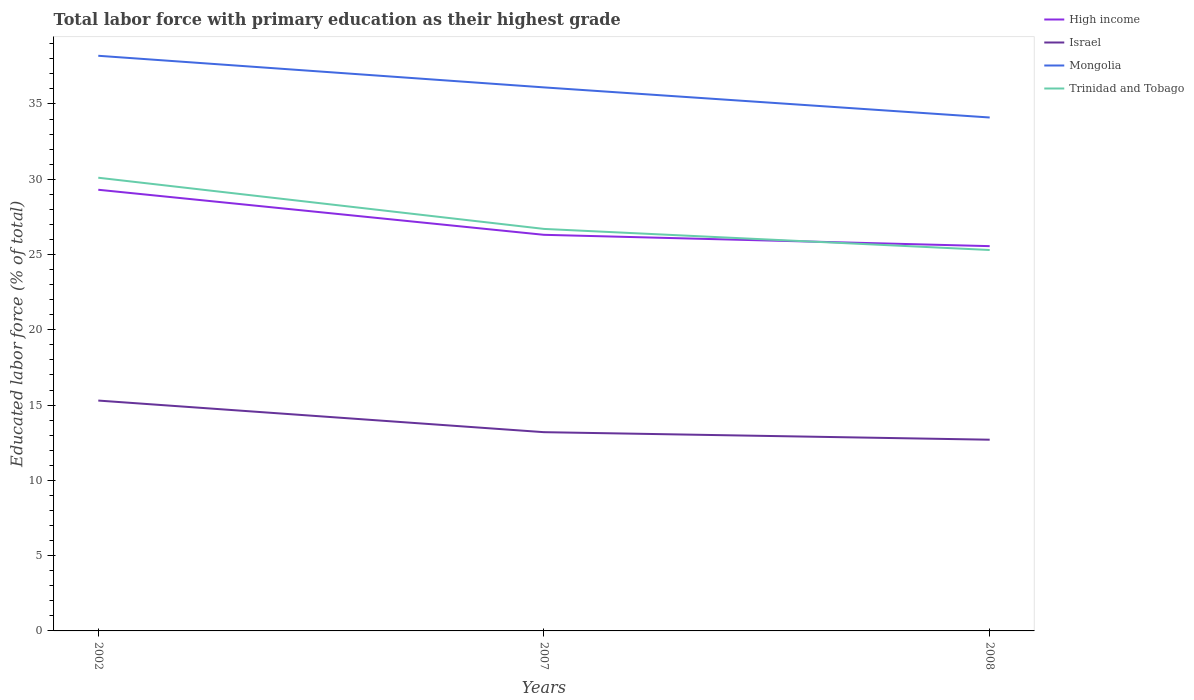Across all years, what is the maximum percentage of total labor force with primary education in Trinidad and Tobago?
Provide a succinct answer. 25.3. In which year was the percentage of total labor force with primary education in High income maximum?
Give a very brief answer. 2008. What is the difference between the highest and the second highest percentage of total labor force with primary education in Trinidad and Tobago?
Your answer should be very brief. 4.8. Are the values on the major ticks of Y-axis written in scientific E-notation?
Give a very brief answer. No. Does the graph contain any zero values?
Offer a very short reply. No. Where does the legend appear in the graph?
Offer a terse response. Top right. How many legend labels are there?
Make the answer very short. 4. How are the legend labels stacked?
Ensure brevity in your answer.  Vertical. What is the title of the graph?
Your response must be concise. Total labor force with primary education as their highest grade. What is the label or title of the X-axis?
Provide a short and direct response. Years. What is the label or title of the Y-axis?
Offer a terse response. Educated labor force (% of total). What is the Educated labor force (% of total) of High income in 2002?
Ensure brevity in your answer.  29.3. What is the Educated labor force (% of total) of Israel in 2002?
Provide a short and direct response. 15.3. What is the Educated labor force (% of total) of Mongolia in 2002?
Provide a succinct answer. 38.2. What is the Educated labor force (% of total) in Trinidad and Tobago in 2002?
Your response must be concise. 30.1. What is the Educated labor force (% of total) in High income in 2007?
Offer a very short reply. 26.31. What is the Educated labor force (% of total) in Israel in 2007?
Your answer should be compact. 13.2. What is the Educated labor force (% of total) of Mongolia in 2007?
Offer a terse response. 36.1. What is the Educated labor force (% of total) of Trinidad and Tobago in 2007?
Keep it short and to the point. 26.7. What is the Educated labor force (% of total) in High income in 2008?
Offer a terse response. 25.56. What is the Educated labor force (% of total) of Israel in 2008?
Your answer should be very brief. 12.7. What is the Educated labor force (% of total) of Mongolia in 2008?
Offer a terse response. 34.1. What is the Educated labor force (% of total) in Trinidad and Tobago in 2008?
Ensure brevity in your answer.  25.3. Across all years, what is the maximum Educated labor force (% of total) in High income?
Your response must be concise. 29.3. Across all years, what is the maximum Educated labor force (% of total) of Israel?
Ensure brevity in your answer.  15.3. Across all years, what is the maximum Educated labor force (% of total) in Mongolia?
Provide a short and direct response. 38.2. Across all years, what is the maximum Educated labor force (% of total) in Trinidad and Tobago?
Offer a very short reply. 30.1. Across all years, what is the minimum Educated labor force (% of total) of High income?
Your response must be concise. 25.56. Across all years, what is the minimum Educated labor force (% of total) in Israel?
Make the answer very short. 12.7. Across all years, what is the minimum Educated labor force (% of total) of Mongolia?
Provide a succinct answer. 34.1. Across all years, what is the minimum Educated labor force (% of total) of Trinidad and Tobago?
Keep it short and to the point. 25.3. What is the total Educated labor force (% of total) in High income in the graph?
Your answer should be compact. 81.17. What is the total Educated labor force (% of total) of Israel in the graph?
Ensure brevity in your answer.  41.2. What is the total Educated labor force (% of total) of Mongolia in the graph?
Give a very brief answer. 108.4. What is the total Educated labor force (% of total) in Trinidad and Tobago in the graph?
Your response must be concise. 82.1. What is the difference between the Educated labor force (% of total) of High income in 2002 and that in 2007?
Your answer should be very brief. 2.99. What is the difference between the Educated labor force (% of total) in Mongolia in 2002 and that in 2007?
Offer a very short reply. 2.1. What is the difference between the Educated labor force (% of total) of High income in 2002 and that in 2008?
Your answer should be very brief. 3.74. What is the difference between the Educated labor force (% of total) in Trinidad and Tobago in 2002 and that in 2008?
Give a very brief answer. 4.8. What is the difference between the Educated labor force (% of total) of High income in 2007 and that in 2008?
Ensure brevity in your answer.  0.75. What is the difference between the Educated labor force (% of total) in High income in 2002 and the Educated labor force (% of total) in Israel in 2007?
Keep it short and to the point. 16.1. What is the difference between the Educated labor force (% of total) in High income in 2002 and the Educated labor force (% of total) in Mongolia in 2007?
Make the answer very short. -6.8. What is the difference between the Educated labor force (% of total) in High income in 2002 and the Educated labor force (% of total) in Trinidad and Tobago in 2007?
Make the answer very short. 2.6. What is the difference between the Educated labor force (% of total) in Israel in 2002 and the Educated labor force (% of total) in Mongolia in 2007?
Keep it short and to the point. -20.8. What is the difference between the Educated labor force (% of total) of Mongolia in 2002 and the Educated labor force (% of total) of Trinidad and Tobago in 2007?
Provide a succinct answer. 11.5. What is the difference between the Educated labor force (% of total) of High income in 2002 and the Educated labor force (% of total) of Israel in 2008?
Your answer should be very brief. 16.6. What is the difference between the Educated labor force (% of total) in High income in 2002 and the Educated labor force (% of total) in Mongolia in 2008?
Provide a succinct answer. -4.8. What is the difference between the Educated labor force (% of total) of High income in 2002 and the Educated labor force (% of total) of Trinidad and Tobago in 2008?
Your answer should be compact. 4. What is the difference between the Educated labor force (% of total) of Israel in 2002 and the Educated labor force (% of total) of Mongolia in 2008?
Give a very brief answer. -18.8. What is the difference between the Educated labor force (% of total) in Israel in 2002 and the Educated labor force (% of total) in Trinidad and Tobago in 2008?
Your answer should be compact. -10. What is the difference between the Educated labor force (% of total) of High income in 2007 and the Educated labor force (% of total) of Israel in 2008?
Offer a terse response. 13.61. What is the difference between the Educated labor force (% of total) in High income in 2007 and the Educated labor force (% of total) in Mongolia in 2008?
Keep it short and to the point. -7.79. What is the difference between the Educated labor force (% of total) of High income in 2007 and the Educated labor force (% of total) of Trinidad and Tobago in 2008?
Keep it short and to the point. 1.01. What is the difference between the Educated labor force (% of total) of Israel in 2007 and the Educated labor force (% of total) of Mongolia in 2008?
Your answer should be compact. -20.9. What is the average Educated labor force (% of total) in High income per year?
Ensure brevity in your answer.  27.06. What is the average Educated labor force (% of total) of Israel per year?
Offer a very short reply. 13.73. What is the average Educated labor force (% of total) of Mongolia per year?
Keep it short and to the point. 36.13. What is the average Educated labor force (% of total) in Trinidad and Tobago per year?
Keep it short and to the point. 27.37. In the year 2002, what is the difference between the Educated labor force (% of total) of High income and Educated labor force (% of total) of Israel?
Your answer should be very brief. 14. In the year 2002, what is the difference between the Educated labor force (% of total) in High income and Educated labor force (% of total) in Mongolia?
Offer a terse response. -8.9. In the year 2002, what is the difference between the Educated labor force (% of total) in High income and Educated labor force (% of total) in Trinidad and Tobago?
Offer a very short reply. -0.8. In the year 2002, what is the difference between the Educated labor force (% of total) of Israel and Educated labor force (% of total) of Mongolia?
Ensure brevity in your answer.  -22.9. In the year 2002, what is the difference between the Educated labor force (% of total) in Israel and Educated labor force (% of total) in Trinidad and Tobago?
Provide a succinct answer. -14.8. In the year 2007, what is the difference between the Educated labor force (% of total) of High income and Educated labor force (% of total) of Israel?
Make the answer very short. 13.11. In the year 2007, what is the difference between the Educated labor force (% of total) of High income and Educated labor force (% of total) of Mongolia?
Your response must be concise. -9.79. In the year 2007, what is the difference between the Educated labor force (% of total) in High income and Educated labor force (% of total) in Trinidad and Tobago?
Provide a succinct answer. -0.39. In the year 2007, what is the difference between the Educated labor force (% of total) in Israel and Educated labor force (% of total) in Mongolia?
Ensure brevity in your answer.  -22.9. In the year 2007, what is the difference between the Educated labor force (% of total) of Israel and Educated labor force (% of total) of Trinidad and Tobago?
Give a very brief answer. -13.5. In the year 2008, what is the difference between the Educated labor force (% of total) in High income and Educated labor force (% of total) in Israel?
Provide a succinct answer. 12.86. In the year 2008, what is the difference between the Educated labor force (% of total) of High income and Educated labor force (% of total) of Mongolia?
Give a very brief answer. -8.54. In the year 2008, what is the difference between the Educated labor force (% of total) in High income and Educated labor force (% of total) in Trinidad and Tobago?
Your response must be concise. 0.26. In the year 2008, what is the difference between the Educated labor force (% of total) in Israel and Educated labor force (% of total) in Mongolia?
Your answer should be compact. -21.4. In the year 2008, what is the difference between the Educated labor force (% of total) of Israel and Educated labor force (% of total) of Trinidad and Tobago?
Your response must be concise. -12.6. What is the ratio of the Educated labor force (% of total) of High income in 2002 to that in 2007?
Provide a short and direct response. 1.11. What is the ratio of the Educated labor force (% of total) of Israel in 2002 to that in 2007?
Offer a very short reply. 1.16. What is the ratio of the Educated labor force (% of total) of Mongolia in 2002 to that in 2007?
Make the answer very short. 1.06. What is the ratio of the Educated labor force (% of total) of Trinidad and Tobago in 2002 to that in 2007?
Provide a short and direct response. 1.13. What is the ratio of the Educated labor force (% of total) in High income in 2002 to that in 2008?
Provide a succinct answer. 1.15. What is the ratio of the Educated labor force (% of total) in Israel in 2002 to that in 2008?
Your answer should be compact. 1.2. What is the ratio of the Educated labor force (% of total) of Mongolia in 2002 to that in 2008?
Make the answer very short. 1.12. What is the ratio of the Educated labor force (% of total) of Trinidad and Tobago in 2002 to that in 2008?
Your response must be concise. 1.19. What is the ratio of the Educated labor force (% of total) of High income in 2007 to that in 2008?
Offer a terse response. 1.03. What is the ratio of the Educated labor force (% of total) in Israel in 2007 to that in 2008?
Offer a very short reply. 1.04. What is the ratio of the Educated labor force (% of total) in Mongolia in 2007 to that in 2008?
Keep it short and to the point. 1.06. What is the ratio of the Educated labor force (% of total) in Trinidad and Tobago in 2007 to that in 2008?
Your answer should be compact. 1.06. What is the difference between the highest and the second highest Educated labor force (% of total) of High income?
Give a very brief answer. 2.99. What is the difference between the highest and the second highest Educated labor force (% of total) in Trinidad and Tobago?
Your answer should be very brief. 3.4. What is the difference between the highest and the lowest Educated labor force (% of total) in High income?
Your response must be concise. 3.74. What is the difference between the highest and the lowest Educated labor force (% of total) in Israel?
Give a very brief answer. 2.6. 